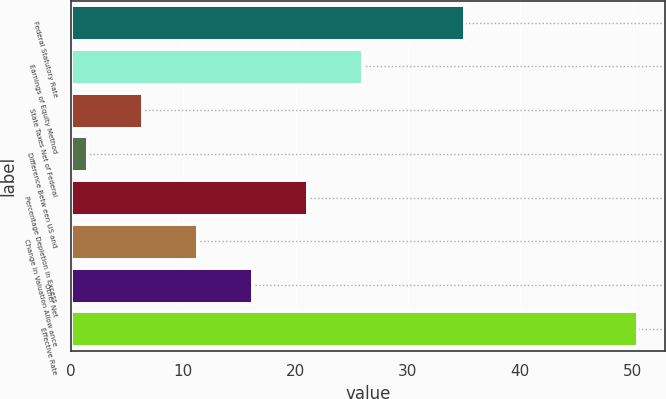Convert chart to OTSL. <chart><loc_0><loc_0><loc_500><loc_500><bar_chart><fcel>Federal Statutory Rate<fcel>Earnings of Equity Method<fcel>State Taxes Net of Federal<fcel>Difference Betw een US and<fcel>Percentage Depletion in Excess<fcel>Change in Valuation Allow ance<fcel>Other Net<fcel>Effective Rate<nl><fcel>35<fcel>25.9<fcel>6.3<fcel>1.4<fcel>21<fcel>11.2<fcel>16.1<fcel>50.4<nl></chart> 